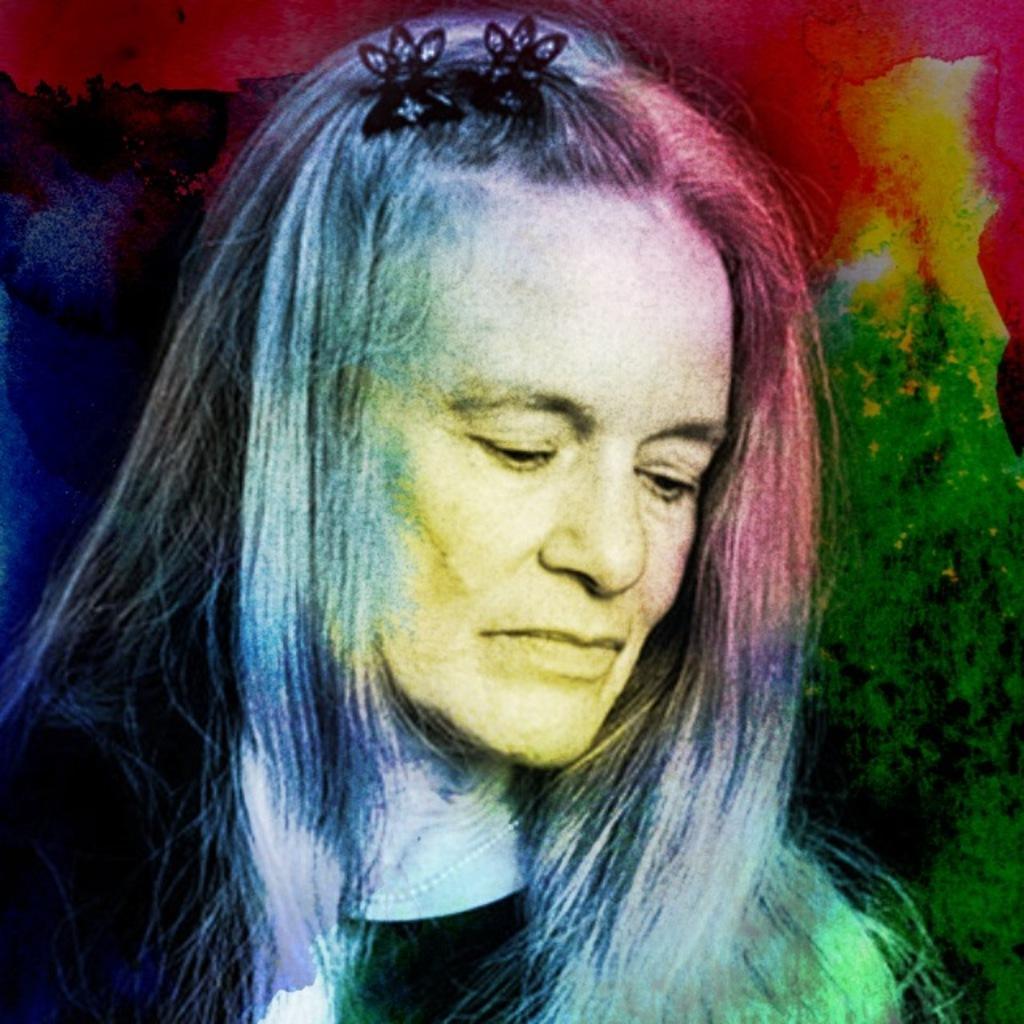Please provide a concise description of this image. In this image there is an art. In the art we can see there is a person's images. On the right side there are different colors. 